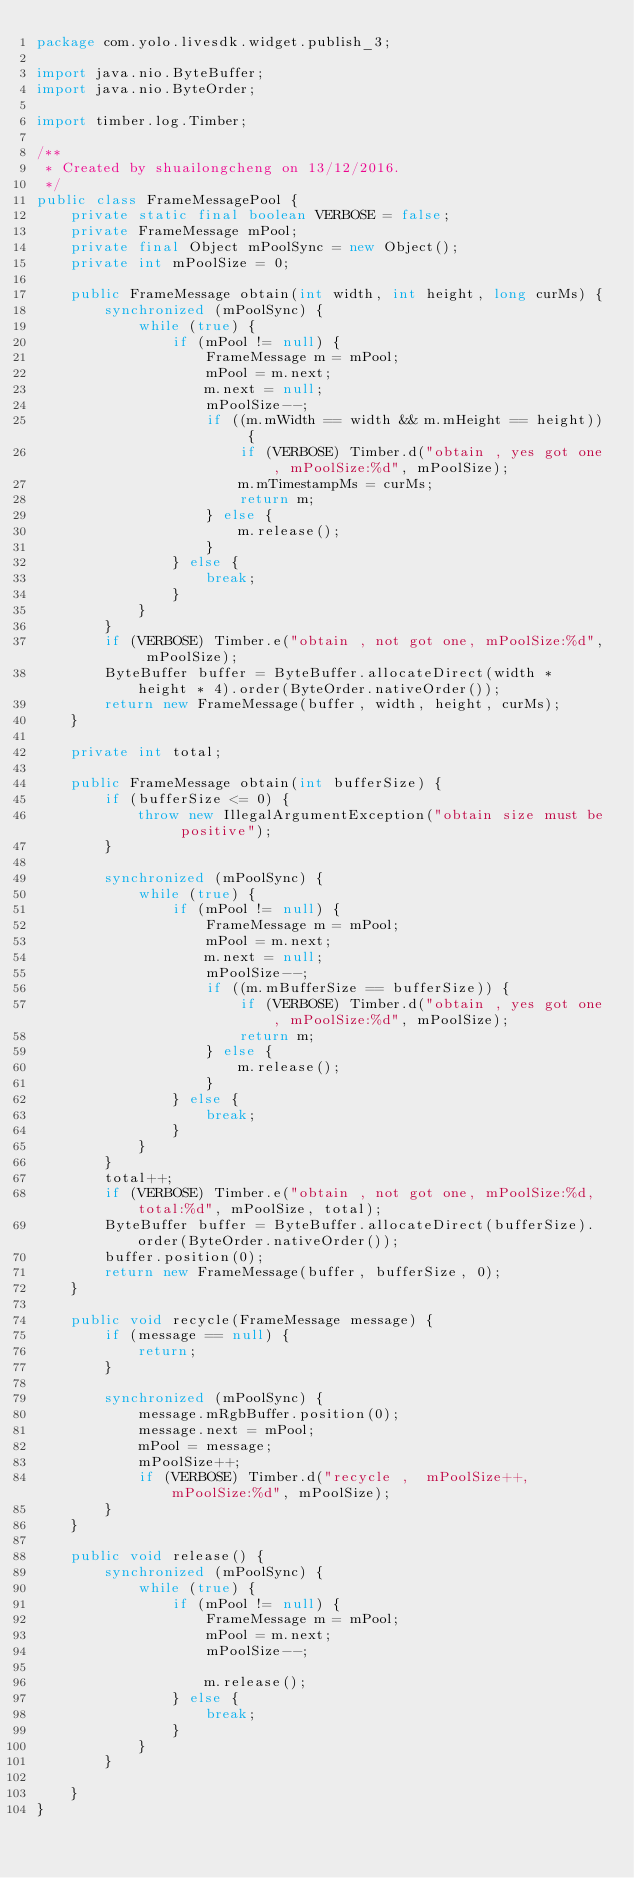Convert code to text. <code><loc_0><loc_0><loc_500><loc_500><_Java_>package com.yolo.livesdk.widget.publish_3;

import java.nio.ByteBuffer;
import java.nio.ByteOrder;

import timber.log.Timber;

/**
 * Created by shuailongcheng on 13/12/2016.
 */
public class FrameMessagePool {
    private static final boolean VERBOSE = false;
    private FrameMessage mPool;
    private final Object mPoolSync = new Object();
    private int mPoolSize = 0;

    public FrameMessage obtain(int width, int height, long curMs) {
        synchronized (mPoolSync) {
            while (true) {
                if (mPool != null) {
                    FrameMessage m = mPool;
                    mPool = m.next;
                    m.next = null;
                    mPoolSize--;
                    if ((m.mWidth == width && m.mHeight == height)) {
                        if (VERBOSE) Timber.d("obtain , yes got one, mPoolSize:%d", mPoolSize);
                        m.mTimestampMs = curMs;
                        return m;
                    } else {
                        m.release();
                    }
                } else {
                    break;
                }
            }
        }
        if (VERBOSE) Timber.e("obtain , not got one, mPoolSize:%d", mPoolSize);
        ByteBuffer buffer = ByteBuffer.allocateDirect(width * height * 4).order(ByteOrder.nativeOrder());
        return new FrameMessage(buffer, width, height, curMs);
    }

    private int total;

    public FrameMessage obtain(int bufferSize) {
        if (bufferSize <= 0) {
            throw new IllegalArgumentException("obtain size must be positive");
        }

        synchronized (mPoolSync) {
            while (true) {
                if (mPool != null) {
                    FrameMessage m = mPool;
                    mPool = m.next;
                    m.next = null;
                    mPoolSize--;
                    if ((m.mBufferSize == bufferSize)) {
                        if (VERBOSE) Timber.d("obtain , yes got one, mPoolSize:%d", mPoolSize);
                        return m;
                    } else {
                        m.release();
                    }
                } else {
                    break;
                }
            }
        }
        total++;
        if (VERBOSE) Timber.e("obtain , not got one, mPoolSize:%d, total:%d", mPoolSize, total);
        ByteBuffer buffer = ByteBuffer.allocateDirect(bufferSize).order(ByteOrder.nativeOrder());
        buffer.position(0);
        return new FrameMessage(buffer, bufferSize, 0);
    }

    public void recycle(FrameMessage message) {
        if (message == null) {
            return;
        }

        synchronized (mPoolSync) {
            message.mRgbBuffer.position(0);
            message.next = mPool;
            mPool = message;
            mPoolSize++;
            if (VERBOSE) Timber.d("recycle ,  mPoolSize++,  mPoolSize:%d", mPoolSize);
        }
    }

    public void release() {
        synchronized (mPoolSync) {
            while (true) {
                if (mPool != null) {
                    FrameMessage m = mPool;
                    mPool = m.next;
                    mPoolSize--;

                    m.release();
                } else {
                    break;
                }
            }
        }

    }
}
</code> 